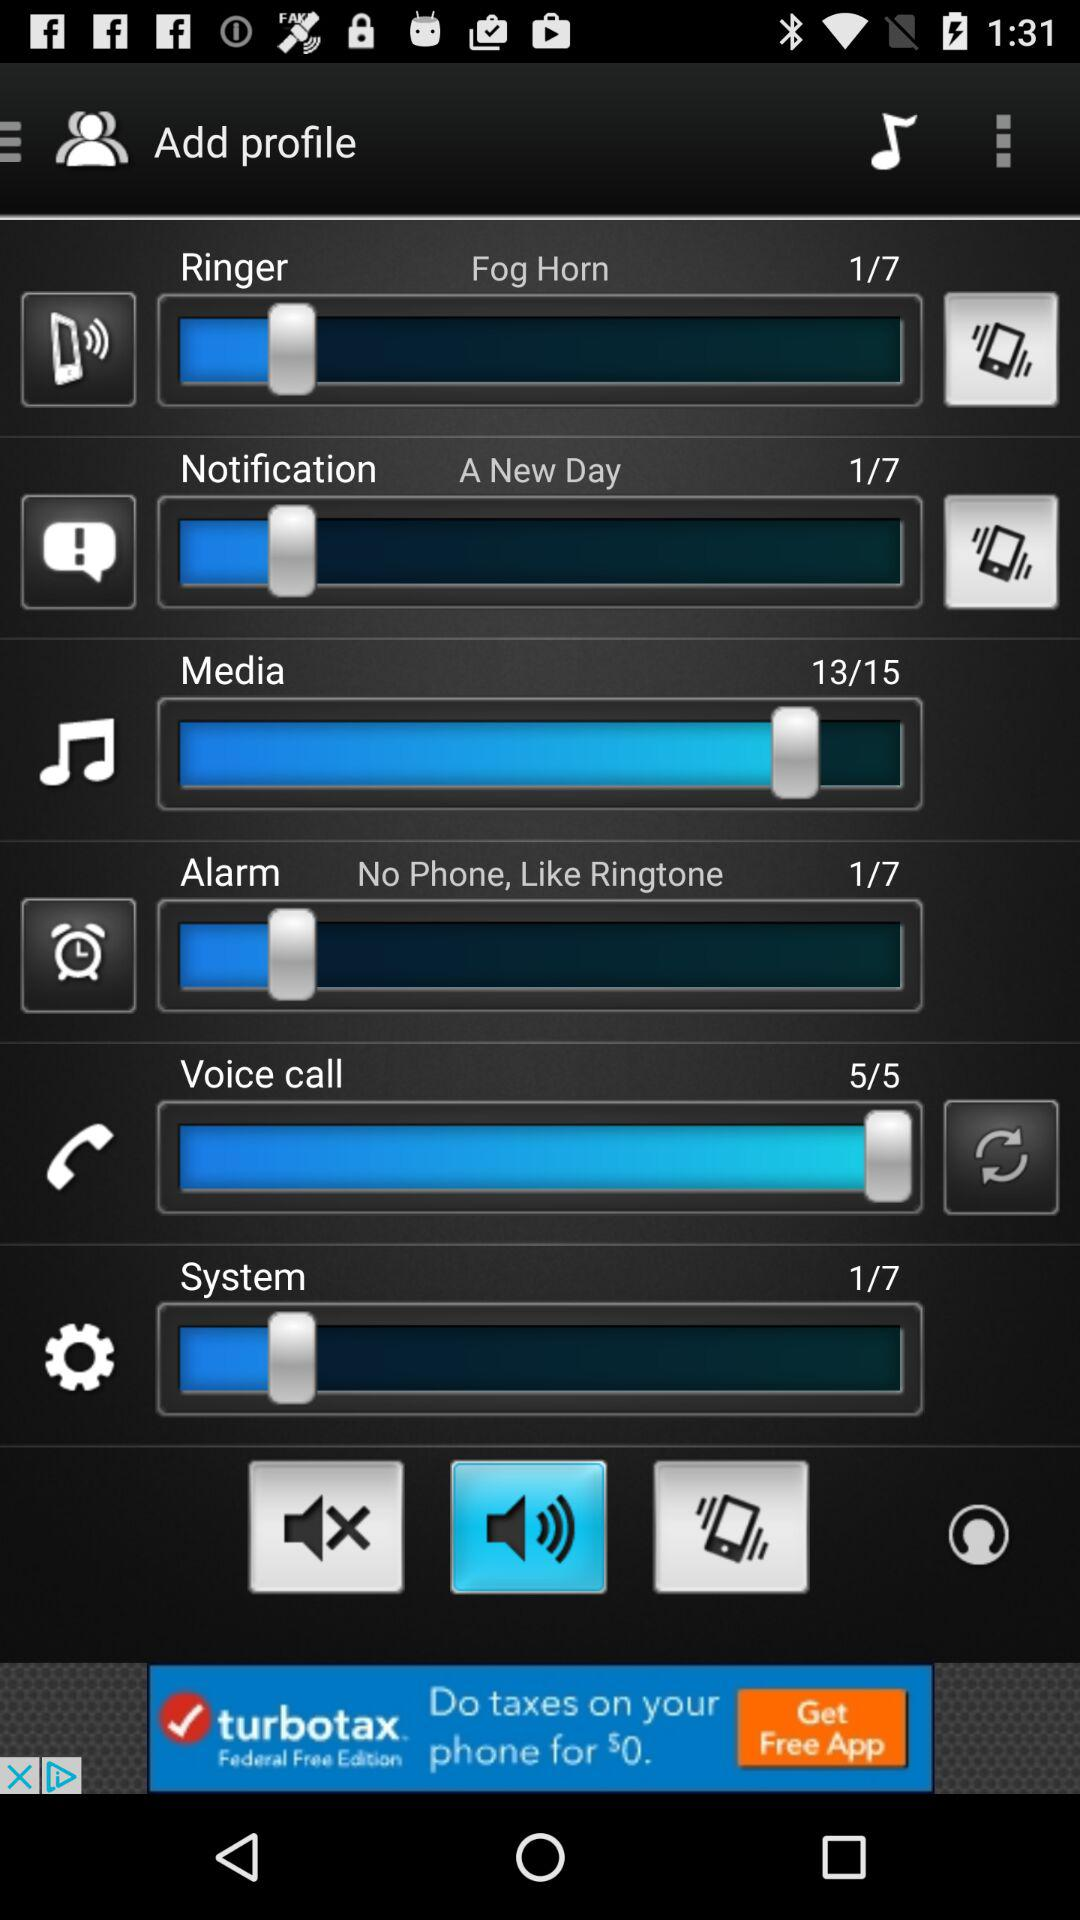What is the ringer tone name? The ringer tone name is "Fog Horn". 